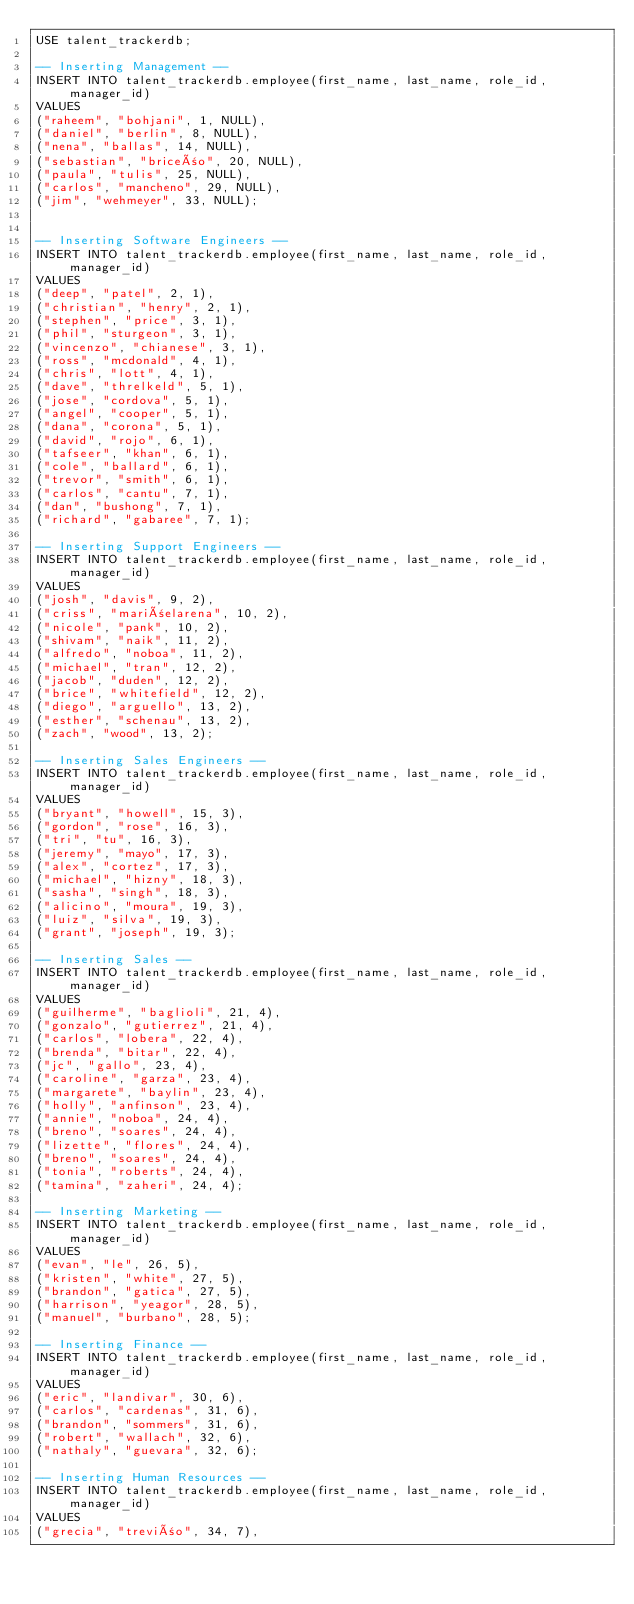Convert code to text. <code><loc_0><loc_0><loc_500><loc_500><_SQL_>USE talent_trackerdb;

-- Inserting Management --
INSERT INTO talent_trackerdb.employee(first_name, last_name, role_id, manager_id)
VALUES 
("raheem", "bohjani", 1, NULL),
("daniel", "berlin", 8, NULL),
("nena", "ballas", 14, NULL),
("sebastian", "briceño", 20, NULL),
("paula", "tulis", 25, NULL),
("carlos", "mancheno", 29, NULL),
("jim", "wehmeyer", 33, NULL);


-- Inserting Software Engineers --
INSERT INTO talent_trackerdb.employee(first_name, last_name, role_id, manager_id)
VALUES 
("deep", "patel", 2, 1),
("christian", "henry", 2, 1),
("stephen", "price", 3, 1),
("phil", "sturgeon", 3, 1),
("vincenzo", "chianese", 3, 1),
("ross", "mcdonald", 4, 1),
("chris", "lott", 4, 1),
("dave", "threlkeld", 5, 1),
("jose", "cordova", 5, 1),
("angel", "cooper", 5, 1),
("dana", "corona", 5, 1),
("david", "rojo", 6, 1),
("tafseer", "khan", 6, 1),
("cole", "ballard", 6, 1),
("trevor", "smith", 6, 1),
("carlos", "cantu", 7, 1),
("dan", "bushong", 7, 1),
("richard", "gabaree", 7, 1);

-- Inserting Support Engineers --
INSERT INTO talent_trackerdb.employee(first_name, last_name, role_id, manager_id)
VALUES 
("josh", "davis", 9, 2),
("criss", "mariñelarena", 10, 2),
("nicole", "pank", 10, 2),
("shivam", "naik", 11, 2),
("alfredo", "noboa", 11, 2),
("michael", "tran", 12, 2),
("jacob", "duden", 12, 2),
("brice", "whitefield", 12, 2),
("diego", "arguello", 13, 2),
("esther", "schenau", 13, 2),
("zach", "wood", 13, 2);

-- Inserting Sales Engineers --
INSERT INTO talent_trackerdb.employee(first_name, last_name, role_id, manager_id)
VALUES 
("bryant", "howell", 15, 3),
("gordon", "rose", 16, 3),
("tri", "tu", 16, 3),
("jeremy", "mayo", 17, 3),
("alex", "cortez", 17, 3),
("michael", "hizny", 18, 3),
("sasha", "singh", 18, 3),
("alicino", "moura", 19, 3),
("luiz", "silva", 19, 3),
("grant", "joseph", 19, 3);

-- Inserting Sales --
INSERT INTO talent_trackerdb.employee(first_name, last_name, role_id, manager_id)
VALUES 
("guilherme", "baglioli", 21, 4),
("gonzalo", "gutierrez", 21, 4),
("carlos", "lobera", 22, 4),
("brenda", "bitar", 22, 4),
("jc", "gallo", 23, 4),
("caroline", "garza", 23, 4),
("margarete", "baylin", 23, 4),
("holly", "anfinson", 23, 4),
("annie", "noboa", 24, 4),
("breno", "soares", 24, 4),
("lizette", "flores", 24, 4),
("breno", "soares", 24, 4),
("tonia", "roberts", 24, 4),
("tamina", "zaheri", 24, 4);

-- Inserting Marketing --
INSERT INTO talent_trackerdb.employee(first_name, last_name, role_id, manager_id)
VALUES 
("evan", "le", 26, 5),
("kristen", "white", 27, 5),
("brandon", "gatica", 27, 5),
("harrison", "yeagor", 28, 5),
("manuel", "burbano", 28, 5);

-- Inserting Finance --
INSERT INTO talent_trackerdb.employee(first_name, last_name, role_id, manager_id)
VALUES 
("eric", "landivar", 30, 6),
("carlos", "cardenas", 31, 6),
("brandon", "sommers", 31, 6),
("robert", "wallach", 32, 6),
("nathaly", "guevara", 32, 6);

-- Inserting Human Resources --
INSERT INTO talent_trackerdb.employee(first_name, last_name, role_id, manager_id)
VALUES 
("grecia", "treviño", 34, 7),</code> 